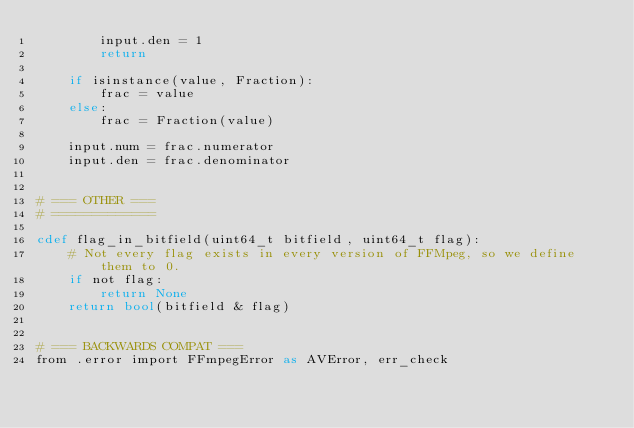Convert code to text. <code><loc_0><loc_0><loc_500><loc_500><_Cython_>        input.den = 1
        return

    if isinstance(value, Fraction):
        frac = value
    else:
        frac = Fraction(value)

    input.num = frac.numerator
    input.den = frac.denominator


# === OTHER ===
# =============

cdef flag_in_bitfield(uint64_t bitfield, uint64_t flag):
    # Not every flag exists in every version of FFMpeg, so we define them to 0.
    if not flag:
        return None
    return bool(bitfield & flag)


# === BACKWARDS COMPAT ===
from .error import FFmpegError as AVError, err_check
</code> 